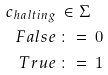<formula> <loc_0><loc_0><loc_500><loc_500>c _ { h a l t i n g } & \, \in \Sigma \\ F a l s e & \, \colon = \, 0 \\ T r u e & \, \colon = \, 1</formula> 